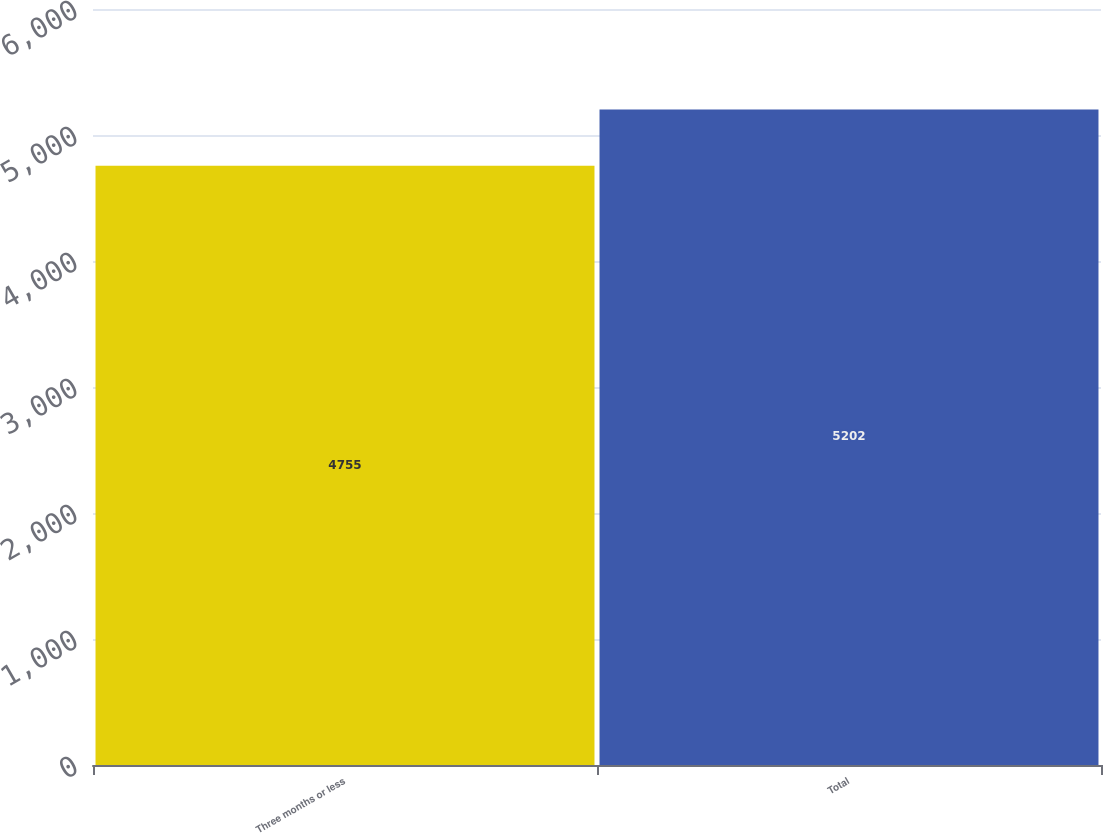Convert chart to OTSL. <chart><loc_0><loc_0><loc_500><loc_500><bar_chart><fcel>Three months or less<fcel>Total<nl><fcel>4755<fcel>5202<nl></chart> 